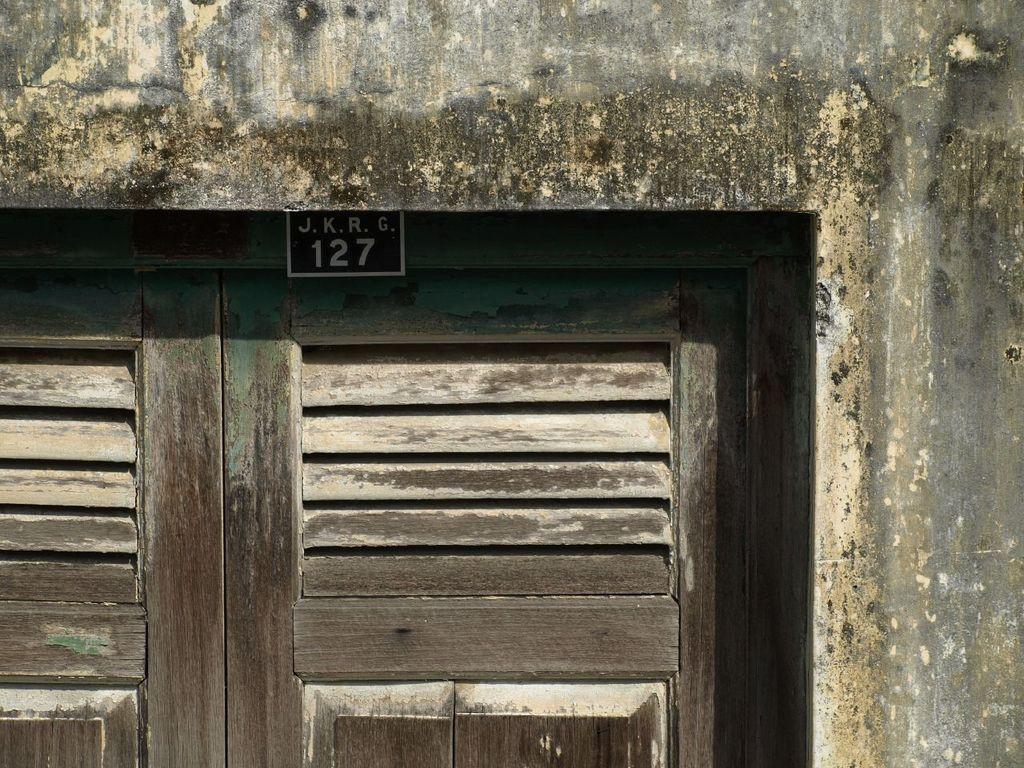Could you give a brief overview of what you see in this image? In this image I can see two doors along with the wall. At the top of the doors I can see a black color paper is attached and I can see some text and numbers on that. 